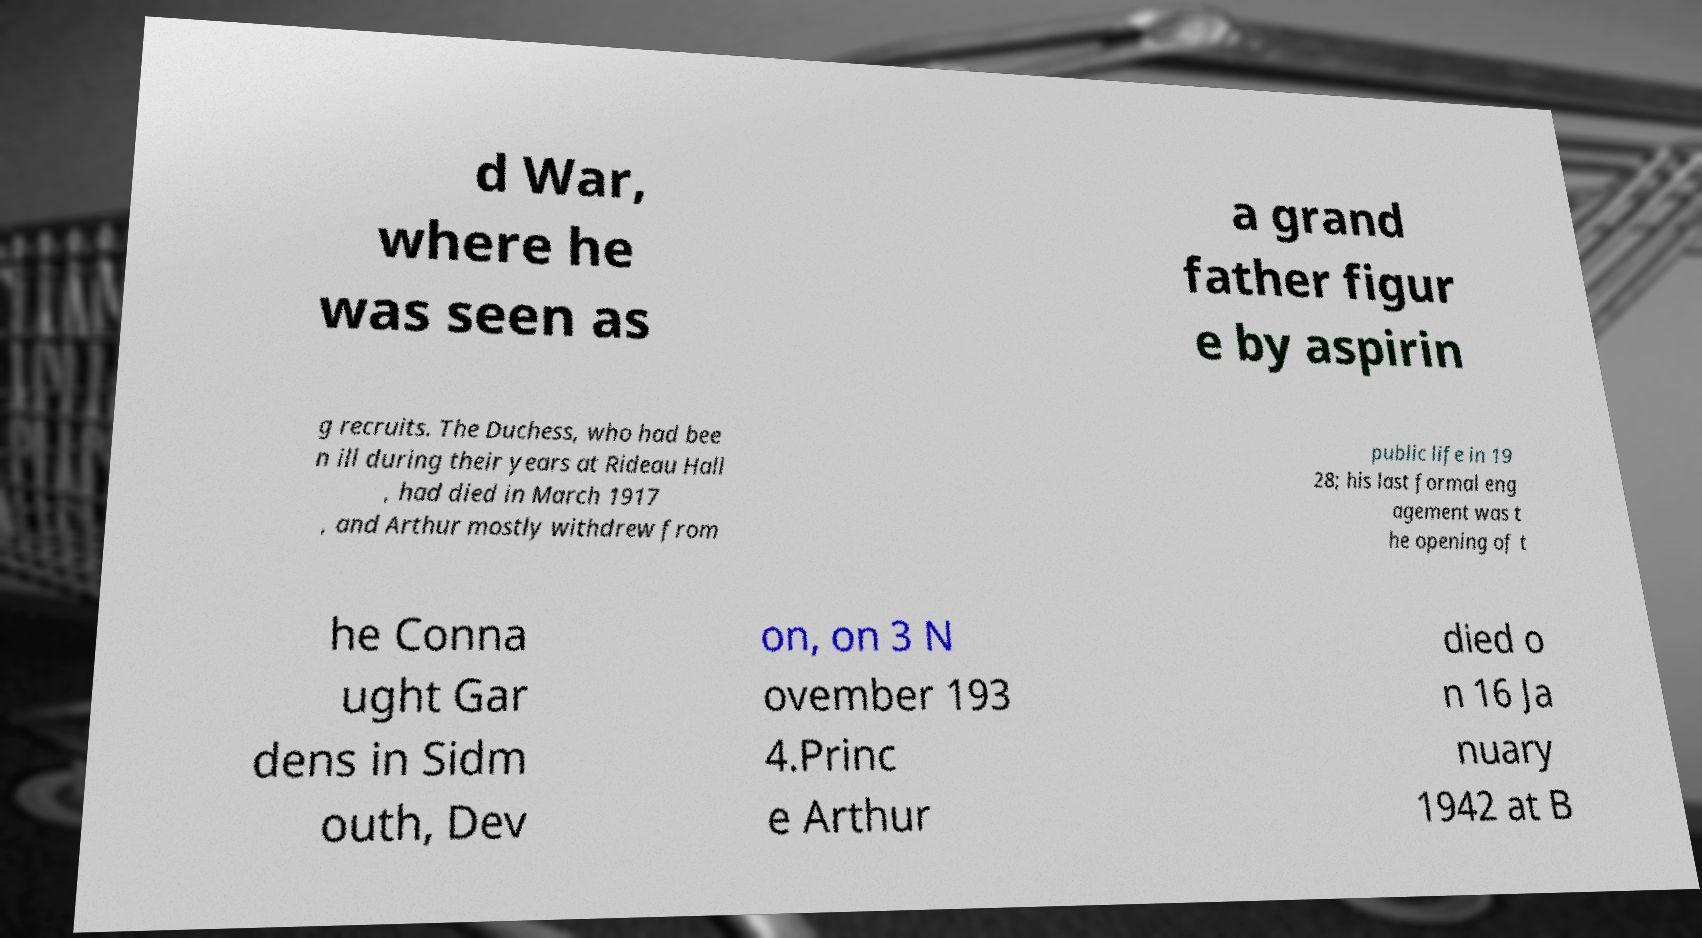Could you assist in decoding the text presented in this image and type it out clearly? d War, where he was seen as a grand father figur e by aspirin g recruits. The Duchess, who had bee n ill during their years at Rideau Hall , had died in March 1917 , and Arthur mostly withdrew from public life in 19 28; his last formal eng agement was t he opening of t he Conna ught Gar dens in Sidm outh, Dev on, on 3 N ovember 193 4.Princ e Arthur died o n 16 Ja nuary 1942 at B 